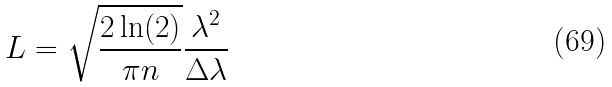<formula> <loc_0><loc_0><loc_500><loc_500>L = \sqrt { \frac { 2 \ln ( 2 ) } { \pi n } } \frac { \lambda ^ { 2 } } { \Delta \lambda }</formula> 